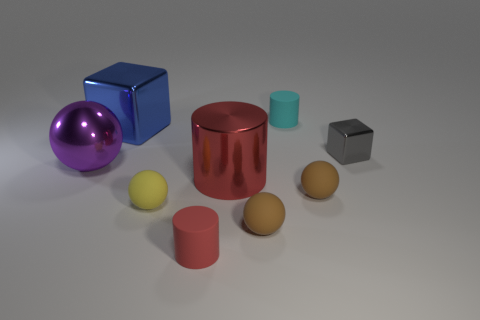What size is the matte cylinder that is the same color as the shiny cylinder?
Ensure brevity in your answer.  Small. Are there any cylinders that have the same size as the cyan matte thing?
Your answer should be compact. Yes. There is a tiny shiny thing that is the same shape as the big blue thing; what is its color?
Provide a succinct answer. Gray. There is a cylinder that is in front of the big red metallic cylinder; is there a gray shiny block on the left side of it?
Give a very brief answer. No. There is a object that is to the left of the blue shiny object; is it the same shape as the small cyan thing?
Your response must be concise. No. What is the shape of the small yellow object?
Your response must be concise. Sphere. How many tiny yellow spheres have the same material as the tiny red cylinder?
Ensure brevity in your answer.  1. Is the color of the tiny block the same as the thing to the left of the big blue metallic thing?
Offer a very short reply. No. What number of big blue metallic objects are there?
Your answer should be compact. 1. Are there any big metallic balls of the same color as the small cube?
Offer a very short reply. No. 